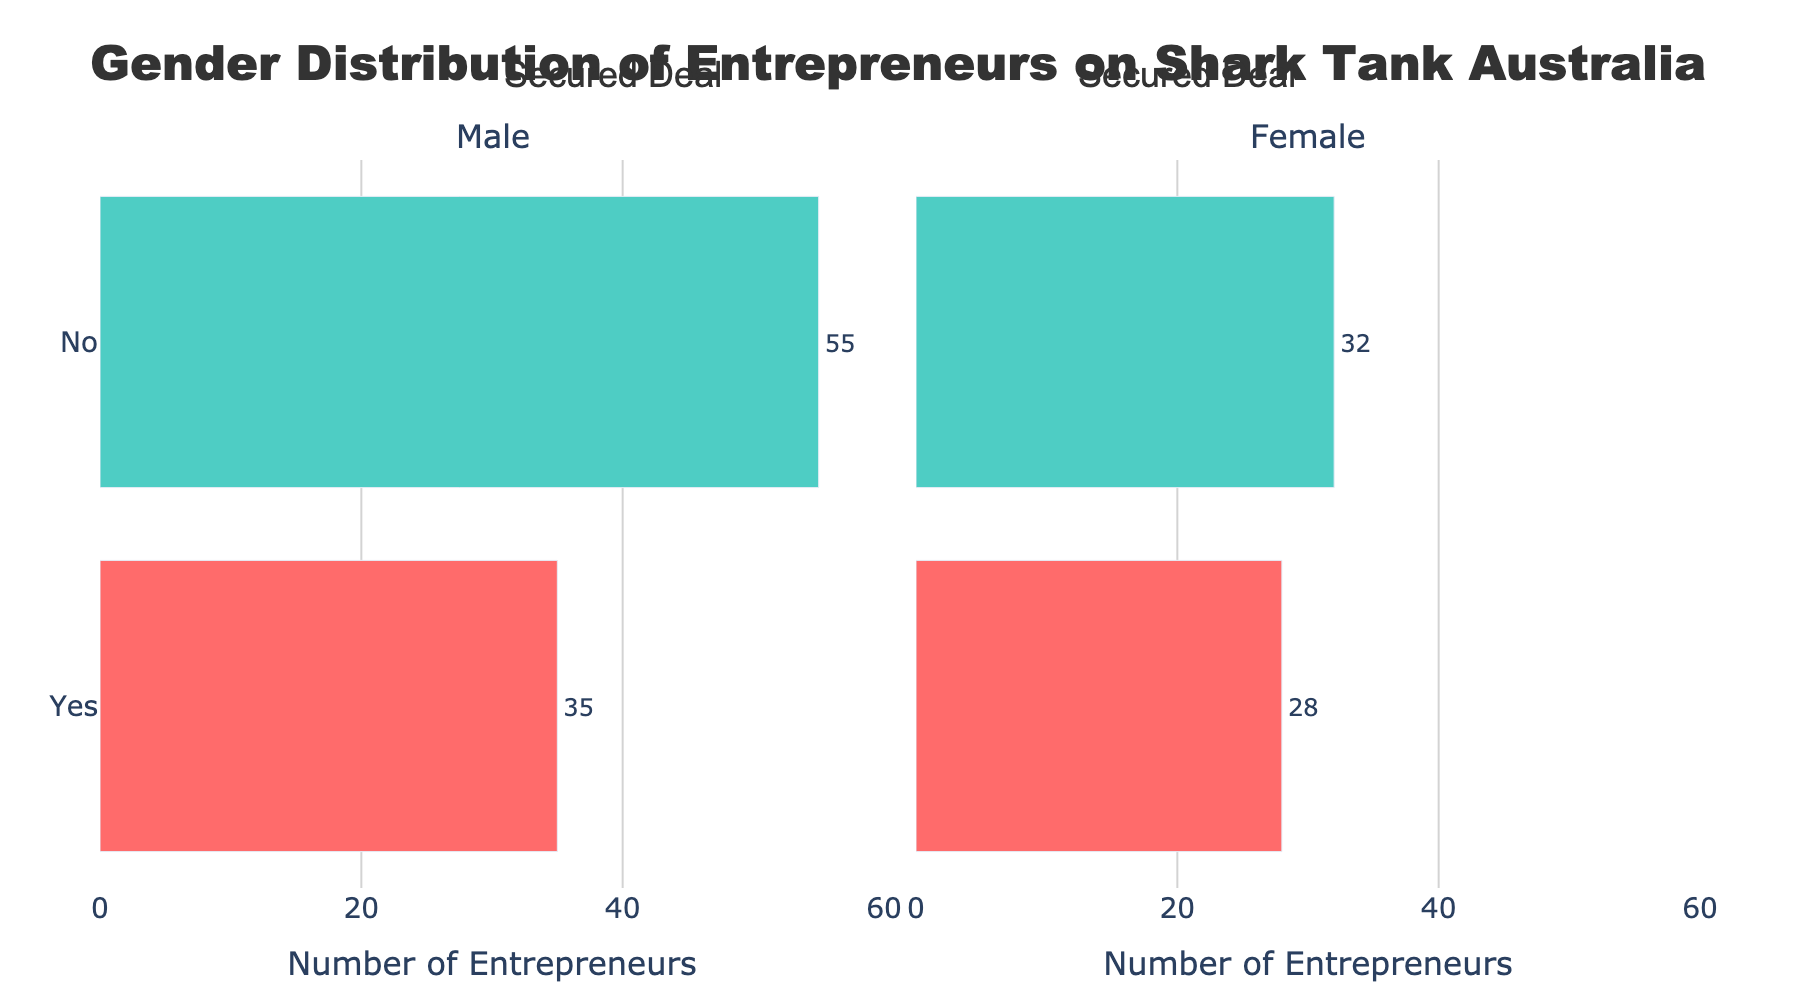What is the total number of male entrepreneurs who secured deals? Look at the bar representing male entrepreneurs who secured deals (Yes) and note the count. The count is 35.
Answer: 35 What is the difference in the number of male entrepreneurs who did not secure deals compared to those who did? Compare the lengths of the bars for male entrepreneurs who did not secure deals (No) and those who did (Yes). The No bar is 55 and the Yes bar is 35, so the difference is 55 - 35 = 20.
Answer: 20 Which gender has a higher number of entrepreneurs that secured deals? Compare the bars for 'Yes' under Male and Female categories. Female entrepreneurs who secured deals have a count of 28, while male entrepreneurs have a count of 35. Therefore, male entrepreneurs have a higher number.
Answer: Male What is the combined total number of male and female entrepreneurs who did not secure deals? Add up the counts from the No category for both Male and Female entrepreneurs. Male (No) is 55 and Female (No) is 32, so the total is 55 + 32 = 87.
Answer: 87 Which visual element does the length of the bar indicate in this figure? The length of each bar represents the number of entrepreneurs who fall into each category (Yes or No) for securing deals, broken down by gender.
Answer: Number of entrepreneurs How many more male entrepreneurs, compared to female entrepreneurs, did not secure deals? Compare the lengths of the bars for the 'No' category under Male and Female genders. Male (No) is 55 and Female (No) is 32. The difference is 55 - 32 = 23.
Answer: 23 What is the ratio of male entrepreneurs who secured deals to those who did not? The number of male entrepreneurs who secured deals (Yes) is 35 and who did not (No) is 55. The ratio is 35:55. Simplifying this ratio by dividing both terms by 5 gives us 7:11.
Answer: 7:11 What do the red bars represent in the figure? The red bars indicate the number of entrepreneurs who secured deals, differentiating by gender (both male and female).
Answer: Secured deals How many total entrepreneurs are represented in the figure? Sum the counts for all categories (Yes and No for both Male and Female). This is 35 (Male Yes) + 28 (Female Yes) + 55 (Male No) + 32 (Female No) = 150.
Answer: 150 